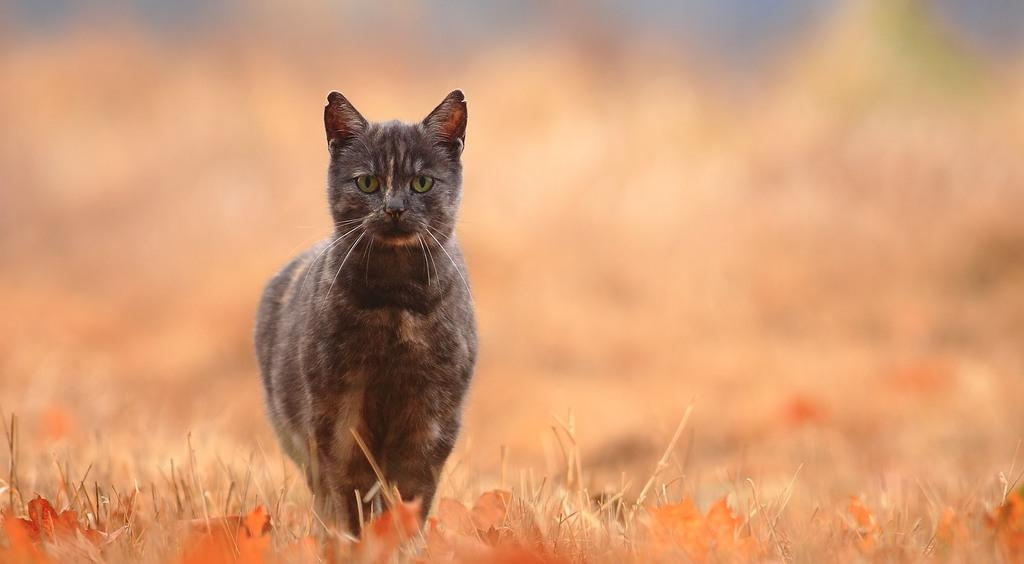What type of animal is in the image? There is a cat in the image. What is on the ground in the image? There is grass and leaves on the ground in the image. Can you describe the background of the image? The background of the image is blurry. What type of dress is the cat wearing in the image? There is no dress present in the image, as cats do not wear clothing. 